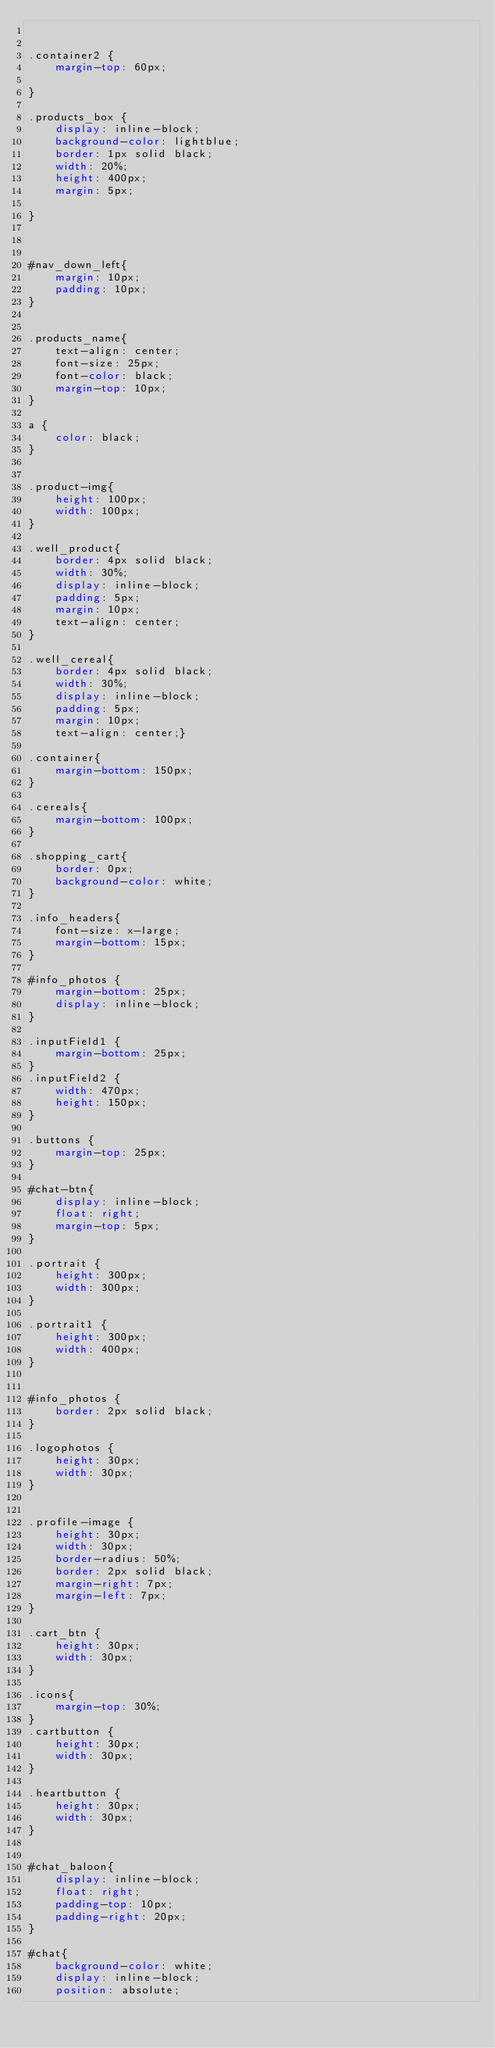<code> <loc_0><loc_0><loc_500><loc_500><_CSS_>

.container2 {
    margin-top: 60px;

}

.products_box {
    display: inline-block;
    background-color: lightblue;
    border: 1px solid black;
    width: 20%;
    height: 400px;
    margin: 5px;

}



#nav_down_left{
    margin: 10px;
    padding: 10px;
}


.products_name{
    text-align: center;
    font-size: 25px;
    font-color: black;
    margin-top: 10px;
}

a {
    color: black;
}


.product-img{
    height: 100px;
    width: 100px;
}

.well_product{
    border: 4px solid black;
    width: 30%;
    display: inline-block;
    padding: 5px;
    margin: 10px;
    text-align: center;
}

.well_cereal{
    border: 4px solid black;
    width: 30%;
    display: inline-block;
    padding: 5px;
    margin: 10px;
    text-align: center;}

.container{
    margin-bottom: 150px;
}

.cereals{
    margin-bottom: 100px;
}

.shopping_cart{
    border: 0px;
    background-color: white;
}

.info_headers{
    font-size: x-large;
    margin-bottom: 15px;
}

#info_photos {
    margin-bottom: 25px;
    display: inline-block;
}

.inputField1 {
    margin-bottom: 25px;
}
.inputField2 {
    width: 470px;
    height: 150px;
}

.buttons {
    margin-top: 25px;
}

#chat-btn{
    display: inline-block;
    float: right;
    margin-top: 5px;
}

.portrait {
    height: 300px;
    width: 300px;
}

.portrait1 {
    height: 300px;
    width: 400px;
}


#info_photos {
    border: 2px solid black;
}

.logophotos {
    height: 30px;
    width: 30px;
}


.profile-image {
    height: 30px;
    width: 30px;
    border-radius: 50%;
    border: 2px solid black;
    margin-right: 7px;
    margin-left: 7px;
}

.cart_btn {
    height: 30px;
    width: 30px;
}

.icons{
    margin-top: 30%;
}
.cartbutton {
    height: 30px;
    width: 30px;
}

.heartbutton {
    height: 30px;
    width: 30px;
}


#chat_baloon{
    display: inline-block;
    float: right;
    padding-top: 10px;
    padding-right: 20px;
}

#chat{
    background-color: white;
    display: inline-block;
    position: absolute;</code> 